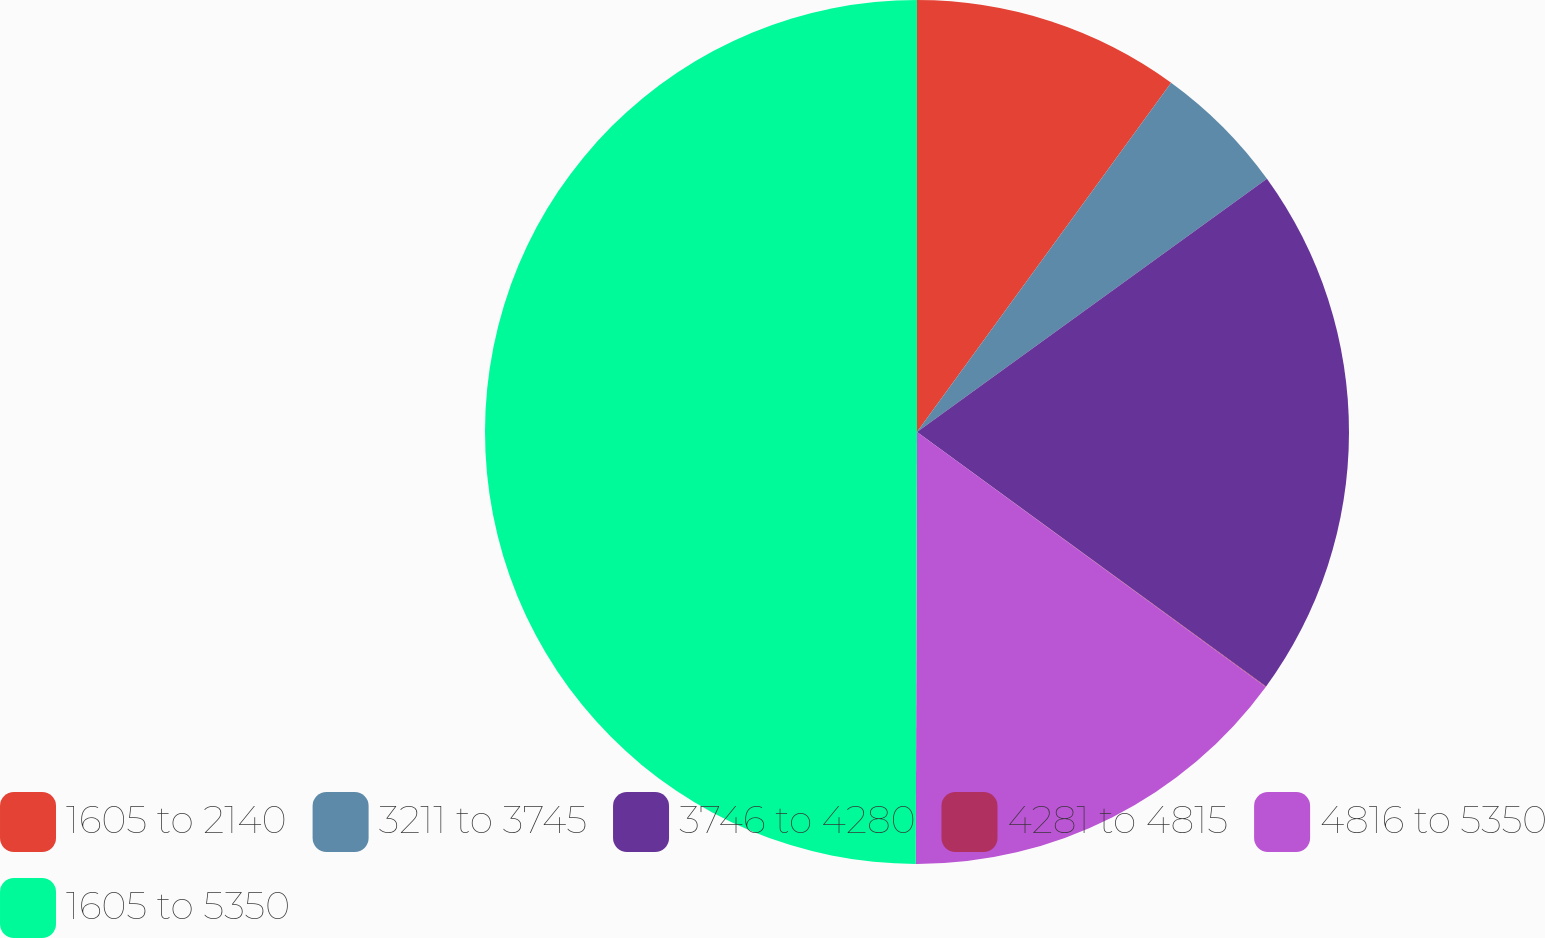<chart> <loc_0><loc_0><loc_500><loc_500><pie_chart><fcel>1605 to 2140<fcel>3211 to 3745<fcel>3746 to 4280<fcel>4281 to 4815<fcel>4816 to 5350<fcel>1605 to 5350<nl><fcel>10.01%<fcel>5.02%<fcel>20.0%<fcel>0.02%<fcel>15.0%<fcel>49.96%<nl></chart> 